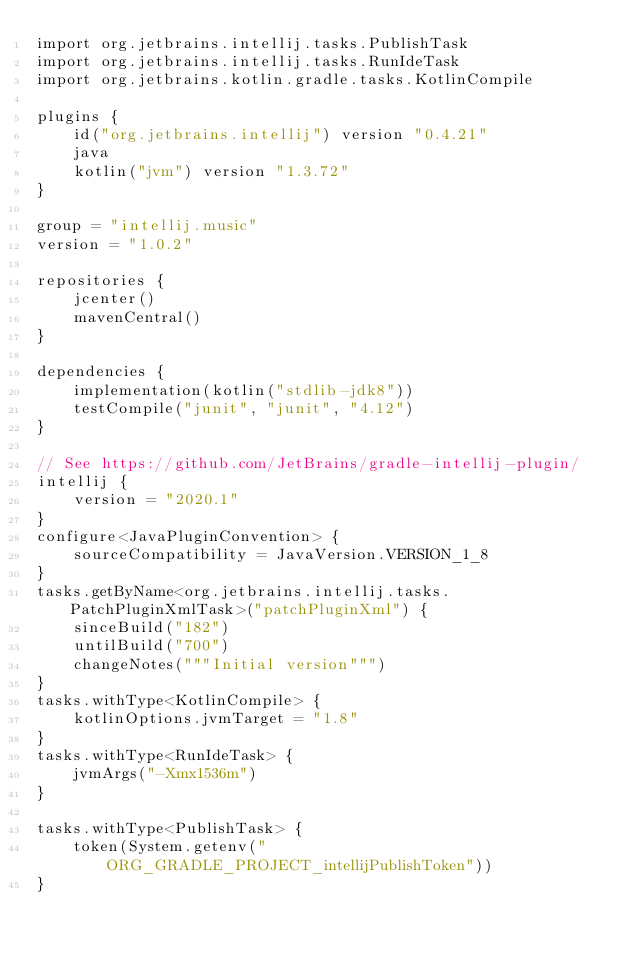<code> <loc_0><loc_0><loc_500><loc_500><_Kotlin_>import org.jetbrains.intellij.tasks.PublishTask
import org.jetbrains.intellij.tasks.RunIdeTask
import org.jetbrains.kotlin.gradle.tasks.KotlinCompile

plugins {
    id("org.jetbrains.intellij") version "0.4.21"
    java
    kotlin("jvm") version "1.3.72"
}

group = "intellij.music"
version = "1.0.2"

repositories {
    jcenter()
    mavenCentral()
}

dependencies {
    implementation(kotlin("stdlib-jdk8"))
    testCompile("junit", "junit", "4.12")
}

// See https://github.com/JetBrains/gradle-intellij-plugin/
intellij {
    version = "2020.1"
}
configure<JavaPluginConvention> {
    sourceCompatibility = JavaVersion.VERSION_1_8
}
tasks.getByName<org.jetbrains.intellij.tasks.PatchPluginXmlTask>("patchPluginXml") {
    sinceBuild("182")
    untilBuild("700")
    changeNotes("""Initial version""")
}
tasks.withType<KotlinCompile> {
    kotlinOptions.jvmTarget = "1.8"
}
tasks.withType<RunIdeTask> {
    jvmArgs("-Xmx1536m")
}

tasks.withType<PublishTask> {
    token(System.getenv("ORG_GRADLE_PROJECT_intellijPublishToken"))
}
</code> 